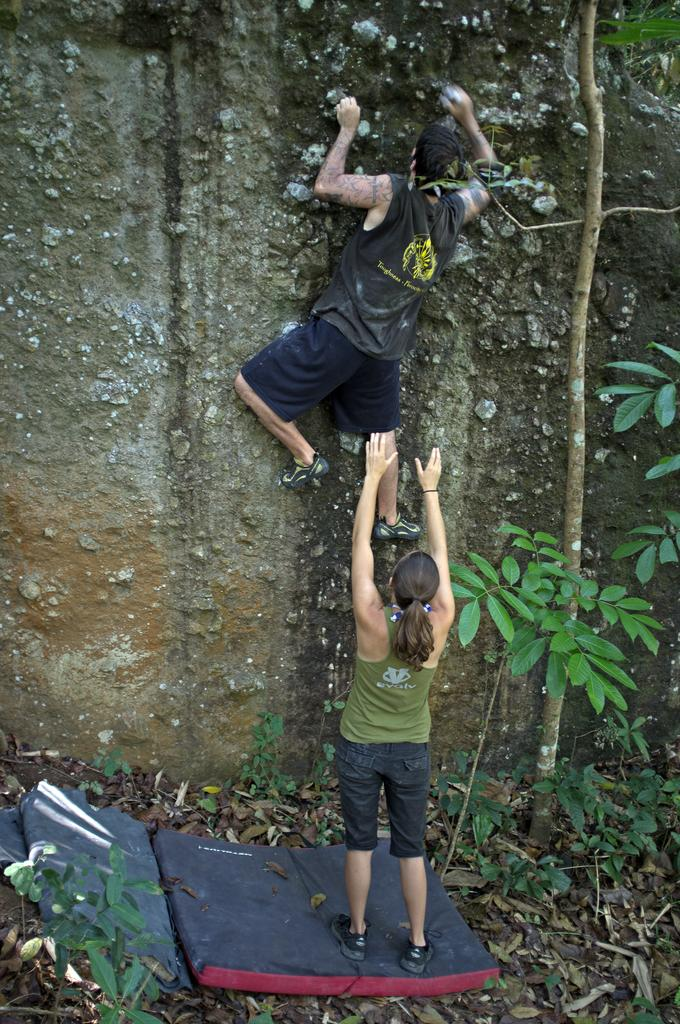How many people are in the image? There are two people in the image. What is one person doing in the image? One person is trying to climb a mountain. What can be seen beside the woman in the image? There is a plant beside the woman. Where is the woman standing in the image? The woman is standing on a bed. What type of animals can be seen at the zoo in the image? There is no zoo present in the image, so it is not possible to determine what, if any, animals might be seen. 